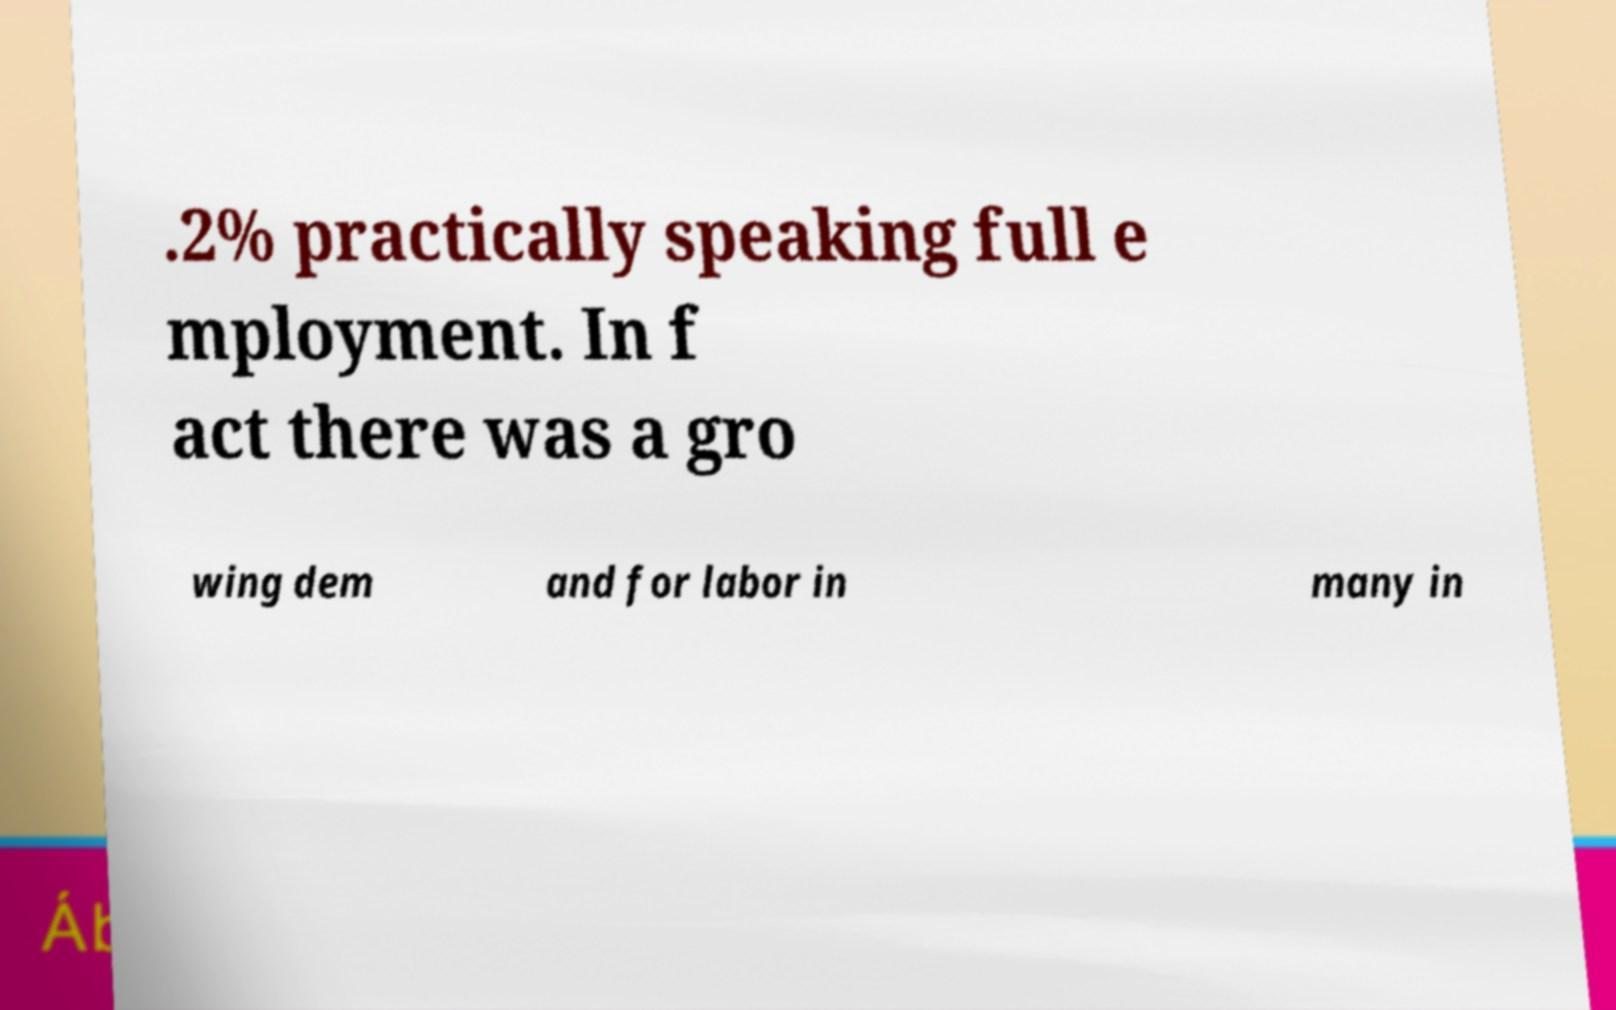I need the written content from this picture converted into text. Can you do that? .2% practically speaking full e mployment. In f act there was a gro wing dem and for labor in many in 